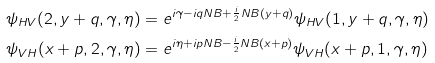<formula> <loc_0><loc_0><loc_500><loc_500>\psi _ { H V } ( 2 , y + q , \gamma , \eta ) & = e ^ { i \gamma - i q N B + \frac { i } { 2 } N B ( y + q ) } \psi _ { H V } ( 1 , y + q , \gamma , \eta ) \\ \psi _ { V H } ( x + p , 2 , \gamma , \eta ) & = e ^ { i \eta + i p N B - \frac { i } { 2 } N B ( x + p ) } \psi _ { V H } ( x + p , 1 , \gamma , \eta )</formula> 